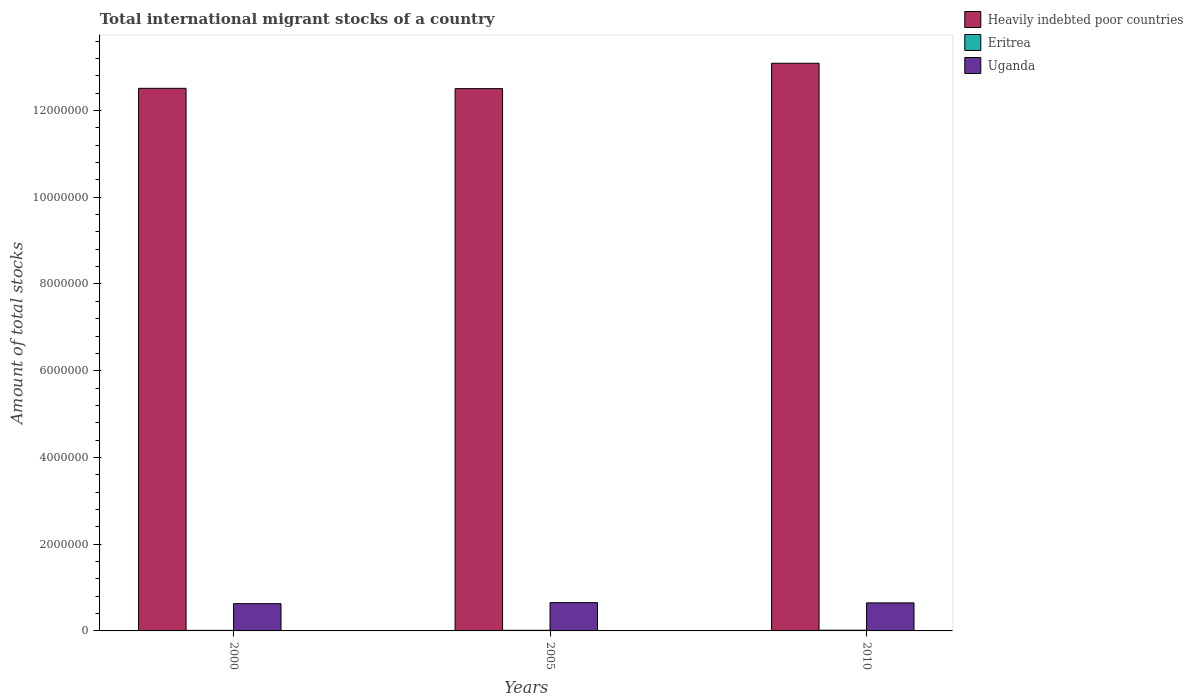How many different coloured bars are there?
Provide a short and direct response. 3. How many groups of bars are there?
Provide a short and direct response. 3. How many bars are there on the 3rd tick from the left?
Give a very brief answer. 3. What is the label of the 3rd group of bars from the left?
Provide a short and direct response. 2010. In how many cases, is the number of bars for a given year not equal to the number of legend labels?
Keep it short and to the point. 0. What is the amount of total stocks in in Uganda in 2005?
Your response must be concise. 6.52e+05. Across all years, what is the maximum amount of total stocks in in Uganda?
Make the answer very short. 6.52e+05. Across all years, what is the minimum amount of total stocks in in Eritrea?
Provide a succinct answer. 1.30e+04. What is the total amount of total stocks in in Uganda in the graph?
Provide a short and direct response. 1.93e+06. What is the difference between the amount of total stocks in in Heavily indebted poor countries in 2005 and that in 2010?
Make the answer very short. -5.85e+05. What is the difference between the amount of total stocks in in Eritrea in 2000 and the amount of total stocks in in Heavily indebted poor countries in 2005?
Provide a short and direct response. -1.25e+07. What is the average amount of total stocks in in Heavily indebted poor countries per year?
Keep it short and to the point. 1.27e+07. In the year 2010, what is the difference between the amount of total stocks in in Heavily indebted poor countries and amount of total stocks in in Eritrea?
Offer a terse response. 1.31e+07. What is the ratio of the amount of total stocks in in Eritrea in 2000 to that in 2010?
Ensure brevity in your answer.  0.79. Is the amount of total stocks in in Eritrea in 2000 less than that in 2005?
Keep it short and to the point. Yes. Is the difference between the amount of total stocks in in Heavily indebted poor countries in 2000 and 2005 greater than the difference between the amount of total stocks in in Eritrea in 2000 and 2005?
Offer a very short reply. Yes. What is the difference between the highest and the second highest amount of total stocks in in Eritrea?
Provide a succinct answer. 1872. What is the difference between the highest and the lowest amount of total stocks in in Eritrea?
Provide a short and direct response. 3532. In how many years, is the amount of total stocks in in Eritrea greater than the average amount of total stocks in in Eritrea taken over all years?
Make the answer very short. 1. What does the 1st bar from the left in 2005 represents?
Provide a succinct answer. Heavily indebted poor countries. What does the 3rd bar from the right in 2005 represents?
Provide a short and direct response. Heavily indebted poor countries. Is it the case that in every year, the sum of the amount of total stocks in in Heavily indebted poor countries and amount of total stocks in in Uganda is greater than the amount of total stocks in in Eritrea?
Offer a terse response. Yes. How many bars are there?
Keep it short and to the point. 9. Are all the bars in the graph horizontal?
Ensure brevity in your answer.  No. Does the graph contain grids?
Offer a very short reply. No. What is the title of the graph?
Ensure brevity in your answer.  Total international migrant stocks of a country. Does "Brunei Darussalam" appear as one of the legend labels in the graph?
Give a very brief answer. No. What is the label or title of the X-axis?
Offer a terse response. Years. What is the label or title of the Y-axis?
Provide a succinct answer. Amount of total stocks. What is the Amount of total stocks in Heavily indebted poor countries in 2000?
Keep it short and to the point. 1.25e+07. What is the Amount of total stocks of Eritrea in 2000?
Your answer should be very brief. 1.30e+04. What is the Amount of total stocks in Uganda in 2000?
Provide a short and direct response. 6.28e+05. What is the Amount of total stocks of Heavily indebted poor countries in 2005?
Your answer should be very brief. 1.25e+07. What is the Amount of total stocks in Eritrea in 2005?
Your answer should be very brief. 1.46e+04. What is the Amount of total stocks of Uganda in 2005?
Give a very brief answer. 6.52e+05. What is the Amount of total stocks in Heavily indebted poor countries in 2010?
Make the answer very short. 1.31e+07. What is the Amount of total stocks of Eritrea in 2010?
Ensure brevity in your answer.  1.65e+04. What is the Amount of total stocks of Uganda in 2010?
Your response must be concise. 6.47e+05. Across all years, what is the maximum Amount of total stocks in Heavily indebted poor countries?
Ensure brevity in your answer.  1.31e+07. Across all years, what is the maximum Amount of total stocks in Eritrea?
Offer a very short reply. 1.65e+04. Across all years, what is the maximum Amount of total stocks of Uganda?
Provide a succinct answer. 6.52e+05. Across all years, what is the minimum Amount of total stocks in Heavily indebted poor countries?
Give a very brief answer. 1.25e+07. Across all years, what is the minimum Amount of total stocks in Eritrea?
Provide a short and direct response. 1.30e+04. Across all years, what is the minimum Amount of total stocks in Uganda?
Offer a terse response. 6.28e+05. What is the total Amount of total stocks in Heavily indebted poor countries in the graph?
Make the answer very short. 3.81e+07. What is the total Amount of total stocks in Eritrea in the graph?
Ensure brevity in your answer.  4.40e+04. What is the total Amount of total stocks in Uganda in the graph?
Give a very brief answer. 1.93e+06. What is the difference between the Amount of total stocks in Heavily indebted poor countries in 2000 and that in 2005?
Offer a very short reply. 7519. What is the difference between the Amount of total stocks of Eritrea in 2000 and that in 2005?
Your answer should be very brief. -1660. What is the difference between the Amount of total stocks of Uganda in 2000 and that in 2005?
Keep it short and to the point. -2.40e+04. What is the difference between the Amount of total stocks in Heavily indebted poor countries in 2000 and that in 2010?
Keep it short and to the point. -5.78e+05. What is the difference between the Amount of total stocks of Eritrea in 2000 and that in 2010?
Offer a terse response. -3532. What is the difference between the Amount of total stocks in Uganda in 2000 and that in 2010?
Your answer should be compact. -1.81e+04. What is the difference between the Amount of total stocks of Heavily indebted poor countries in 2005 and that in 2010?
Provide a succinct answer. -5.85e+05. What is the difference between the Amount of total stocks of Eritrea in 2005 and that in 2010?
Your answer should be very brief. -1872. What is the difference between the Amount of total stocks in Uganda in 2005 and that in 2010?
Your answer should be very brief. 5860. What is the difference between the Amount of total stocks of Heavily indebted poor countries in 2000 and the Amount of total stocks of Eritrea in 2005?
Provide a short and direct response. 1.25e+07. What is the difference between the Amount of total stocks of Heavily indebted poor countries in 2000 and the Amount of total stocks of Uganda in 2005?
Give a very brief answer. 1.19e+07. What is the difference between the Amount of total stocks of Eritrea in 2000 and the Amount of total stocks of Uganda in 2005?
Provide a short and direct response. -6.39e+05. What is the difference between the Amount of total stocks of Heavily indebted poor countries in 2000 and the Amount of total stocks of Eritrea in 2010?
Your response must be concise. 1.25e+07. What is the difference between the Amount of total stocks in Heavily indebted poor countries in 2000 and the Amount of total stocks in Uganda in 2010?
Provide a short and direct response. 1.19e+07. What is the difference between the Amount of total stocks of Eritrea in 2000 and the Amount of total stocks of Uganda in 2010?
Keep it short and to the point. -6.34e+05. What is the difference between the Amount of total stocks of Heavily indebted poor countries in 2005 and the Amount of total stocks of Eritrea in 2010?
Keep it short and to the point. 1.25e+07. What is the difference between the Amount of total stocks of Heavily indebted poor countries in 2005 and the Amount of total stocks of Uganda in 2010?
Your answer should be very brief. 1.19e+07. What is the difference between the Amount of total stocks of Eritrea in 2005 and the Amount of total stocks of Uganda in 2010?
Your response must be concise. -6.32e+05. What is the average Amount of total stocks in Heavily indebted poor countries per year?
Your answer should be very brief. 1.27e+07. What is the average Amount of total stocks in Eritrea per year?
Provide a short and direct response. 1.47e+04. What is the average Amount of total stocks in Uganda per year?
Give a very brief answer. 6.42e+05. In the year 2000, what is the difference between the Amount of total stocks of Heavily indebted poor countries and Amount of total stocks of Eritrea?
Provide a short and direct response. 1.25e+07. In the year 2000, what is the difference between the Amount of total stocks in Heavily indebted poor countries and Amount of total stocks in Uganda?
Your response must be concise. 1.19e+07. In the year 2000, what is the difference between the Amount of total stocks of Eritrea and Amount of total stocks of Uganda?
Provide a short and direct response. -6.15e+05. In the year 2005, what is the difference between the Amount of total stocks of Heavily indebted poor countries and Amount of total stocks of Eritrea?
Provide a short and direct response. 1.25e+07. In the year 2005, what is the difference between the Amount of total stocks of Heavily indebted poor countries and Amount of total stocks of Uganda?
Provide a short and direct response. 1.19e+07. In the year 2005, what is the difference between the Amount of total stocks in Eritrea and Amount of total stocks in Uganda?
Make the answer very short. -6.38e+05. In the year 2010, what is the difference between the Amount of total stocks of Heavily indebted poor countries and Amount of total stocks of Eritrea?
Offer a terse response. 1.31e+07. In the year 2010, what is the difference between the Amount of total stocks in Heavily indebted poor countries and Amount of total stocks in Uganda?
Provide a short and direct response. 1.24e+07. In the year 2010, what is the difference between the Amount of total stocks in Eritrea and Amount of total stocks in Uganda?
Provide a short and direct response. -6.30e+05. What is the ratio of the Amount of total stocks in Heavily indebted poor countries in 2000 to that in 2005?
Offer a very short reply. 1. What is the ratio of the Amount of total stocks of Eritrea in 2000 to that in 2005?
Provide a short and direct response. 0.89. What is the ratio of the Amount of total stocks in Uganda in 2000 to that in 2005?
Provide a short and direct response. 0.96. What is the ratio of the Amount of total stocks in Heavily indebted poor countries in 2000 to that in 2010?
Your response must be concise. 0.96. What is the ratio of the Amount of total stocks of Eritrea in 2000 to that in 2010?
Offer a very short reply. 0.79. What is the ratio of the Amount of total stocks of Heavily indebted poor countries in 2005 to that in 2010?
Offer a terse response. 0.96. What is the ratio of the Amount of total stocks in Eritrea in 2005 to that in 2010?
Ensure brevity in your answer.  0.89. What is the ratio of the Amount of total stocks in Uganda in 2005 to that in 2010?
Offer a very short reply. 1.01. What is the difference between the highest and the second highest Amount of total stocks of Heavily indebted poor countries?
Make the answer very short. 5.78e+05. What is the difference between the highest and the second highest Amount of total stocks of Eritrea?
Your response must be concise. 1872. What is the difference between the highest and the second highest Amount of total stocks in Uganda?
Offer a terse response. 5860. What is the difference between the highest and the lowest Amount of total stocks of Heavily indebted poor countries?
Your answer should be very brief. 5.85e+05. What is the difference between the highest and the lowest Amount of total stocks in Eritrea?
Make the answer very short. 3532. What is the difference between the highest and the lowest Amount of total stocks of Uganda?
Ensure brevity in your answer.  2.40e+04. 